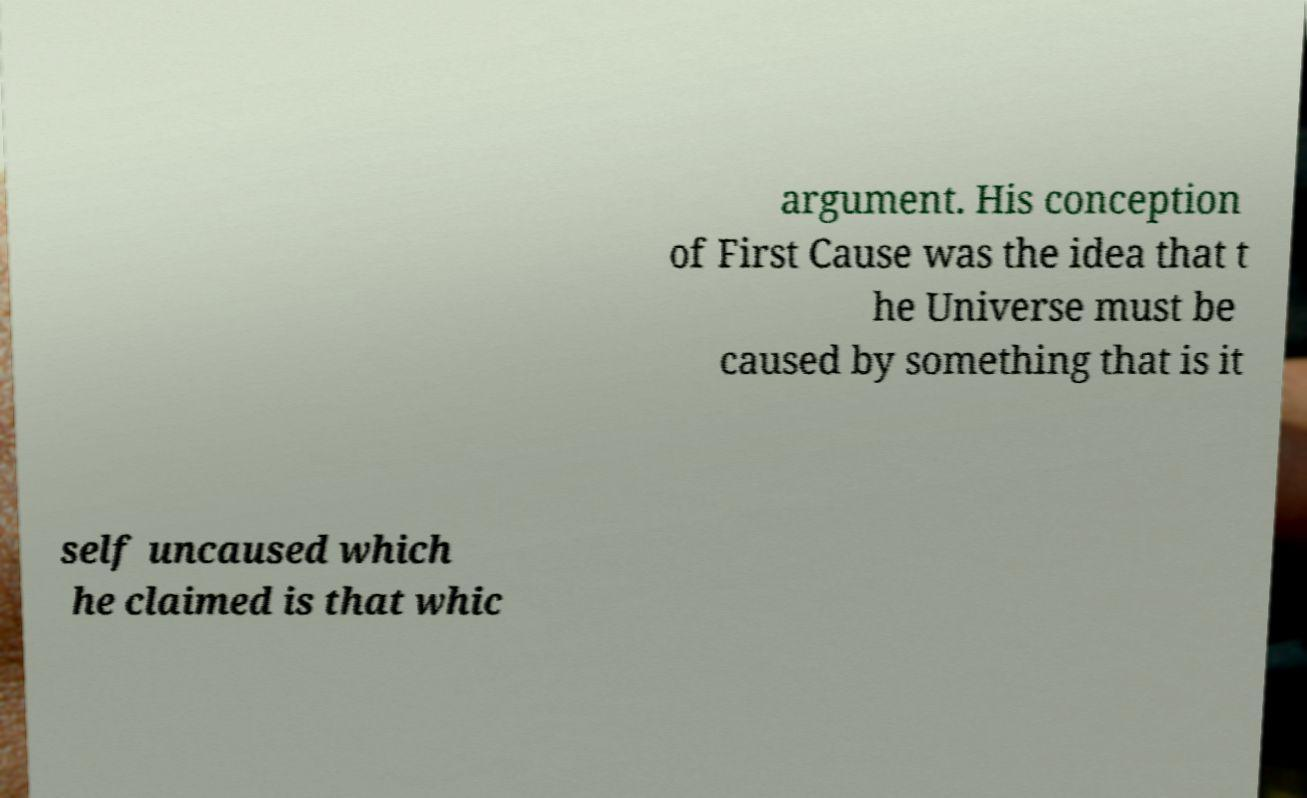I need the written content from this picture converted into text. Can you do that? argument. His conception of First Cause was the idea that t he Universe must be caused by something that is it self uncaused which he claimed is that whic 